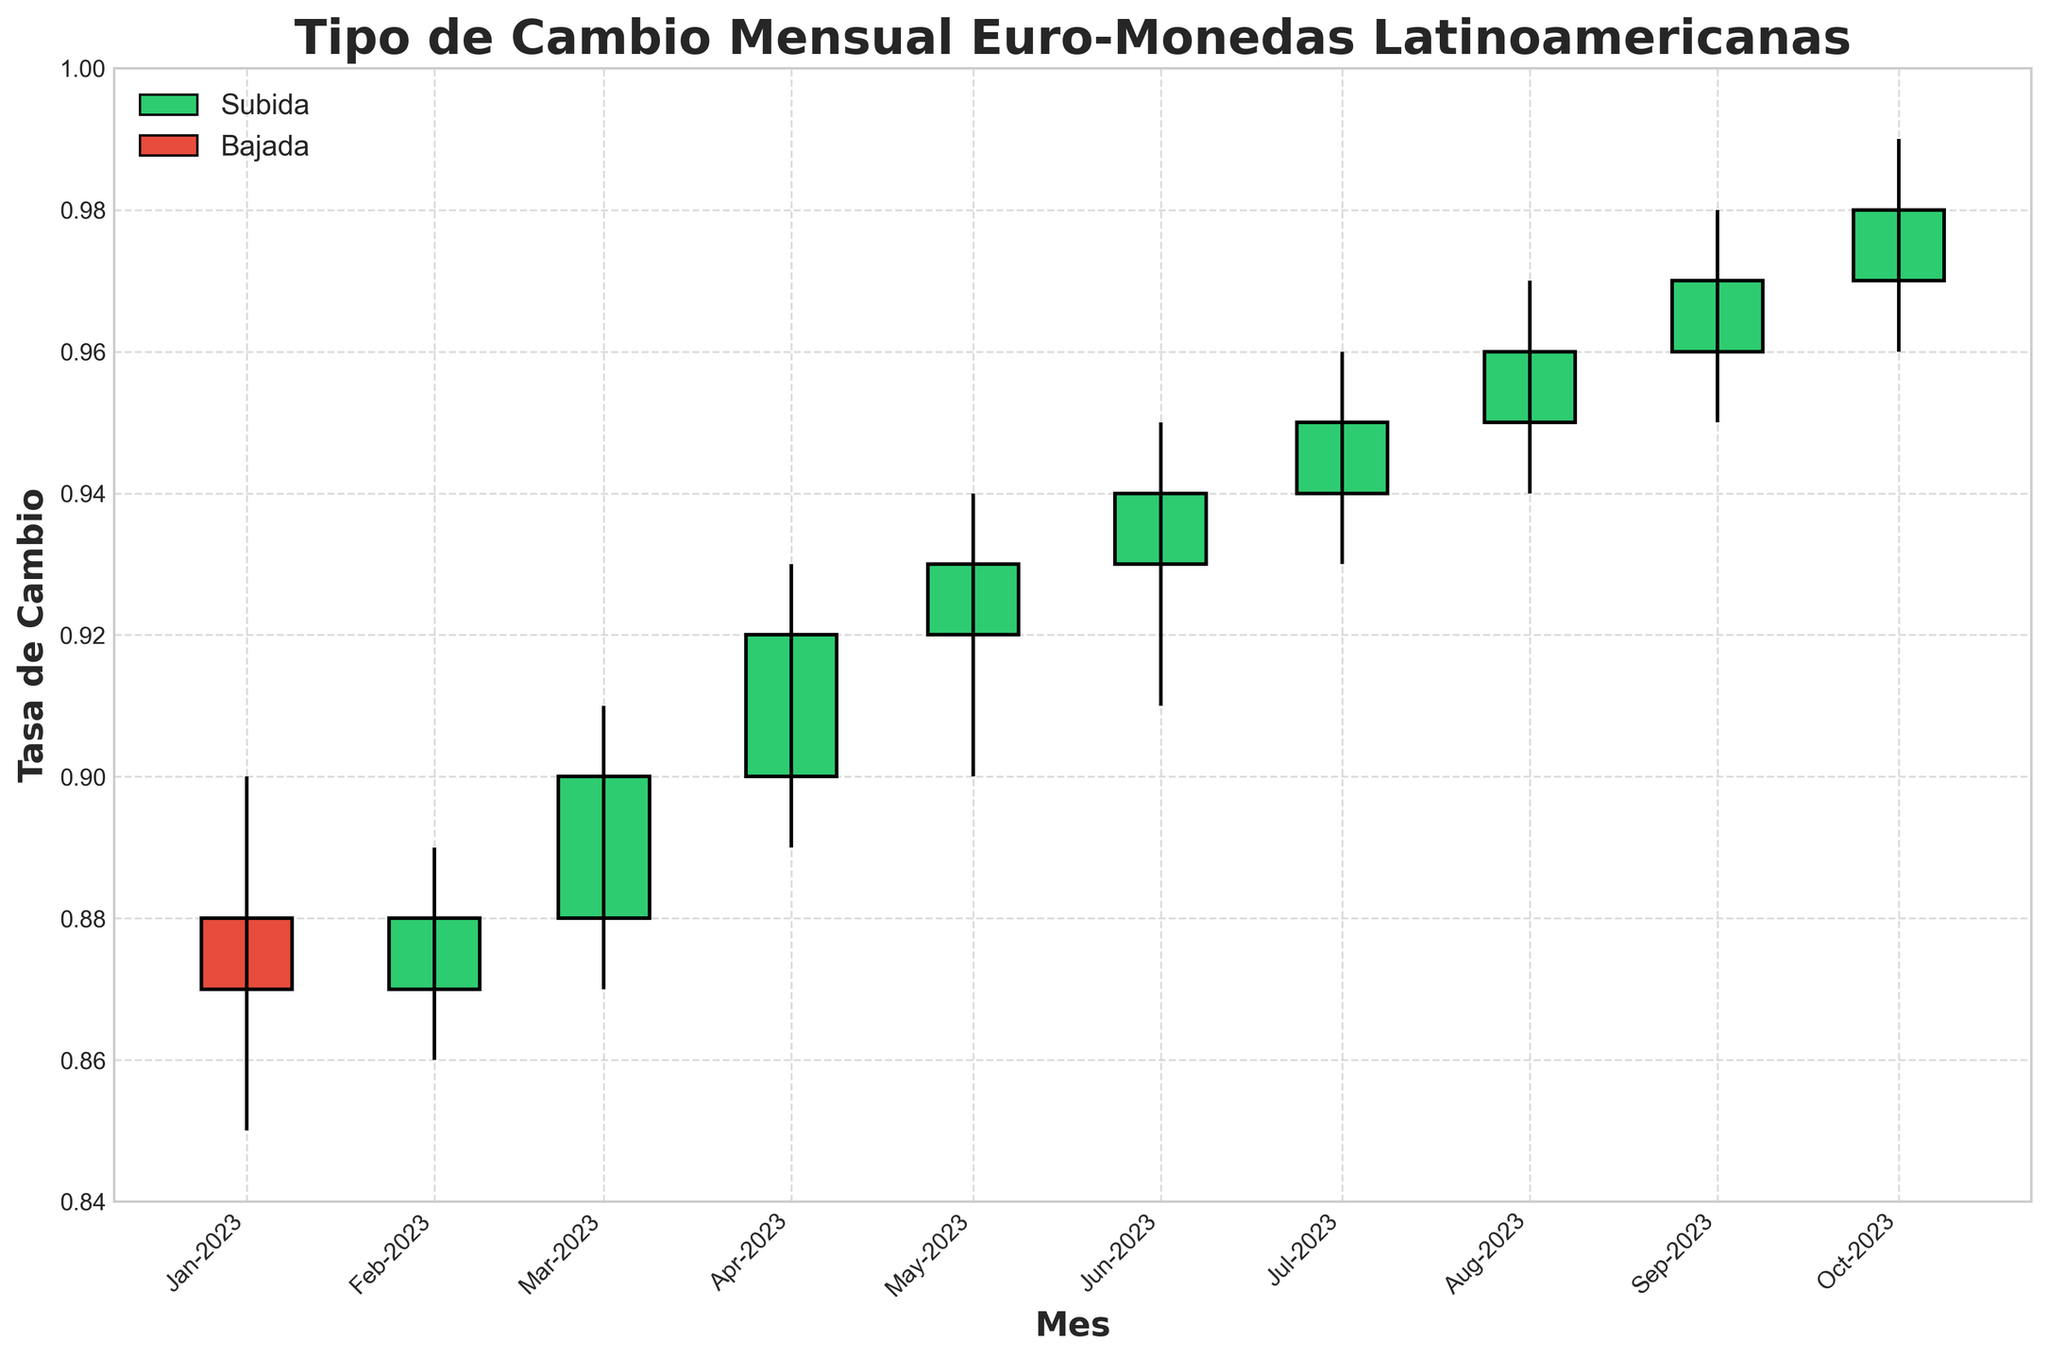¿Cuál es el título del gráfico? El título del gráfico se encuentra en la parte superior del mismo y está en negrita y escrito en español. Dice "Tipo de Cambio Mensual Euro-Monedas Latinoamericanas".
Answer: Tipo de Cambio Mensual Euro-Monedas Latinoamericanas ¿Cuántos meses diferentes se muestran en el gráfico? La etiqueta del eje x está marcada con los nombres de los meses desde enero de 2023 hasta octubre de 2023.
Answer: 10 ¿Cuál es el color utilizado para indicar una subida en la tasa de cambio? Los cuerpos de las velas con subidas están coloreados en verde. Esto se puede ver en la leyenda al lado de la palabra "Subida" y comparando visualmente el gráfico.
Answer: Verde ¿Cuál mes experimentó el menor 'Low' (mínimo)? Observando las líneas verticales que representan los mínimos, enero de 2023 tiene la línea más baja en el gráfico.
Answer: Enero-2023 ¿Cuál es la media del 'Close' de los meses de abril y mayo de 2023? Los valores del 'Close' son 0.92 para abril y 0.93 para mayo. La media se calcula sumando estos valores y dividiendo entre dos: (0.92 + 0.93) / 2.
Answer: 0.925 ¿Cuál mes tuvo el mayor rango de variación (High - Low)? Necesitamos encontrar la diferencia (High - Low) para cada mes y comparar. Marzo-2023 tiene la mayor diferencia con (0.91 - 0.87) = 0.04.
Answer: Marzo-2023 ¿Qué línea tiene la mayor cantidad de subidas sucesivas sin bajas? Observamos las barras verdes consecutivas. Desde abril de 2023 hasta octubre de 2023, hubo subidas sucesivas sin ninguna baja.
Answer: 7 ¿Cuál es la tendencia general observada en el gráfico de marzo a octubre de 2023? Observando las características del gráfico y los colores de las velas, vemos que desde marzo hasta octubre de 2023, la tasa de cambio generalmente ha ido en aumento, con velas verdes predominantes y valores de 'Close' ascendiendo cada mes.
Answer: Ascendente 